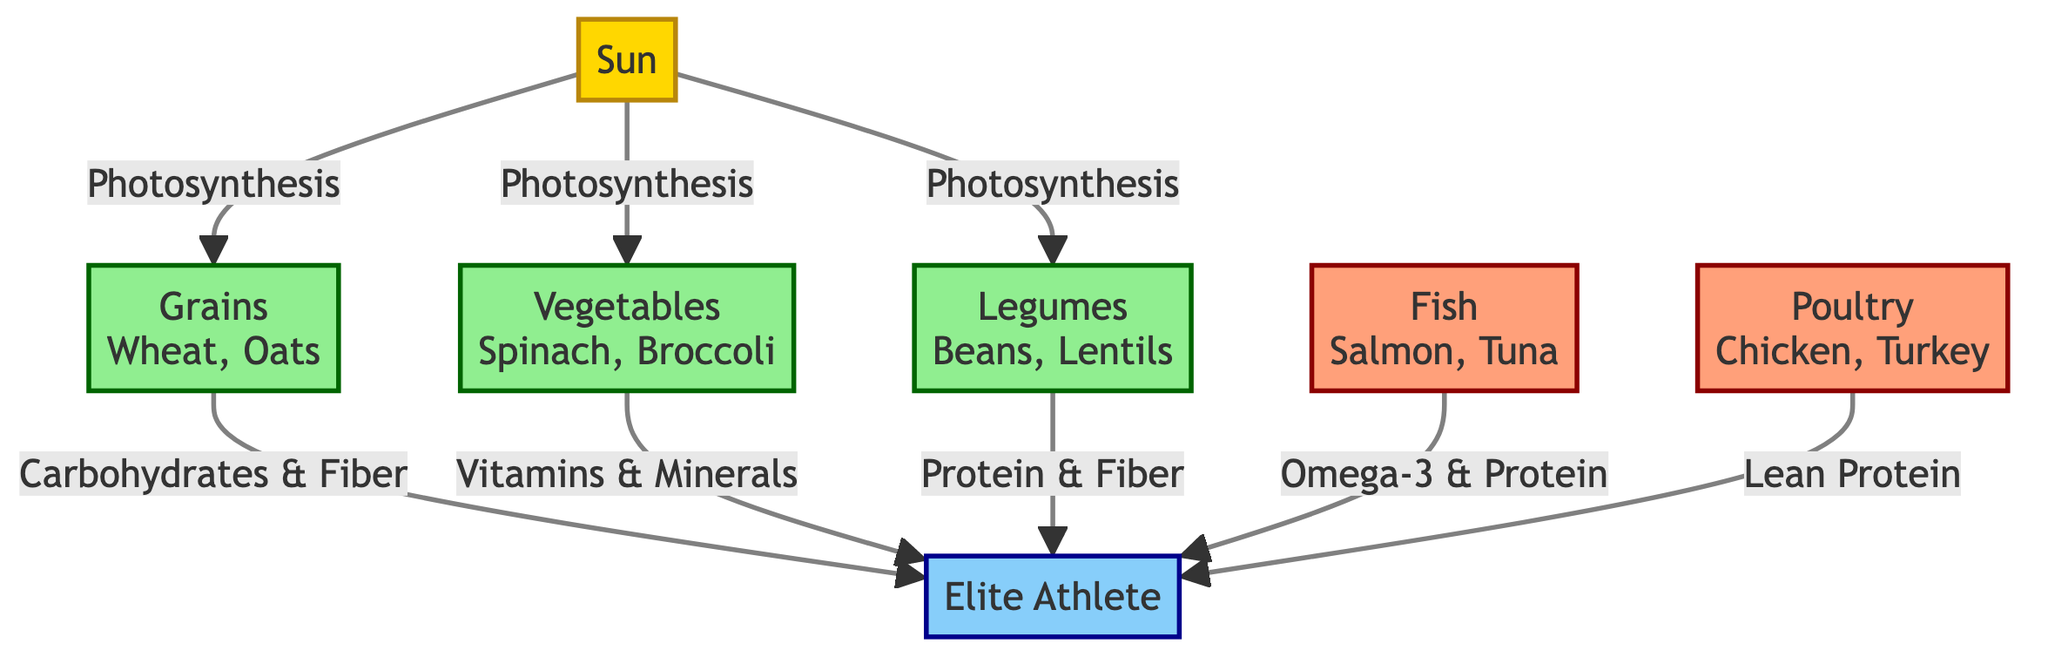What are the primary producers in this food chain? The diagram lists three primary producers: grains, vegetables, and legumes. Each of these connects directly to the sun through the process of photosynthesis.
Answer: Grains, Vegetables, Legumes How many secondary consumers are there in the diagram? The diagram shows two secondary consumers: fish and poultry. Each of them is an essential source of nutrition for the elite athlete.
Answer: 2 What type of nutrients do vegetables provide to the athlete? According to the diagram, vegetables are linked to the athlete and provide vitamins and minerals, which are essential for overall health and performance.
Answer: Vitamins & Minerals Which food source is directly associated with Omega-3 fatty acids? The diagram specifies that fish, which includes salmon and tuna, is the source that provides Omega-3 fatty acids to the athlete, highlighting its nutritional importance.
Answer: Fish What relationship exists between grains and the elite athlete? The diagram indicates that grains supply carbohydrates and fiber to the elite athlete, which are crucial for energy and performance during training.
Answer: Carbohydrates & Fiber Which food supply offers lean protein to athletes? Poultry is identified in the diagram as the food supply that provides lean protein, contributing to muscle recovery and growth for the athlete.
Answer: Poultry How does the sun contribute to the food chain? The sun is the initial source of energy in the diagram, as it fuels the process of photosynthesis, enabling primary producers (grains, vegetables, and legumes) to grow.
Answer: Energy What is the function of legumes in the nutrition of athletes? The diagram states that legumes provide protein and fiber, which are critical for muscle repair and digestive health, thus supporting the athlete's training regimen.
Answer: Protein & Fiber 